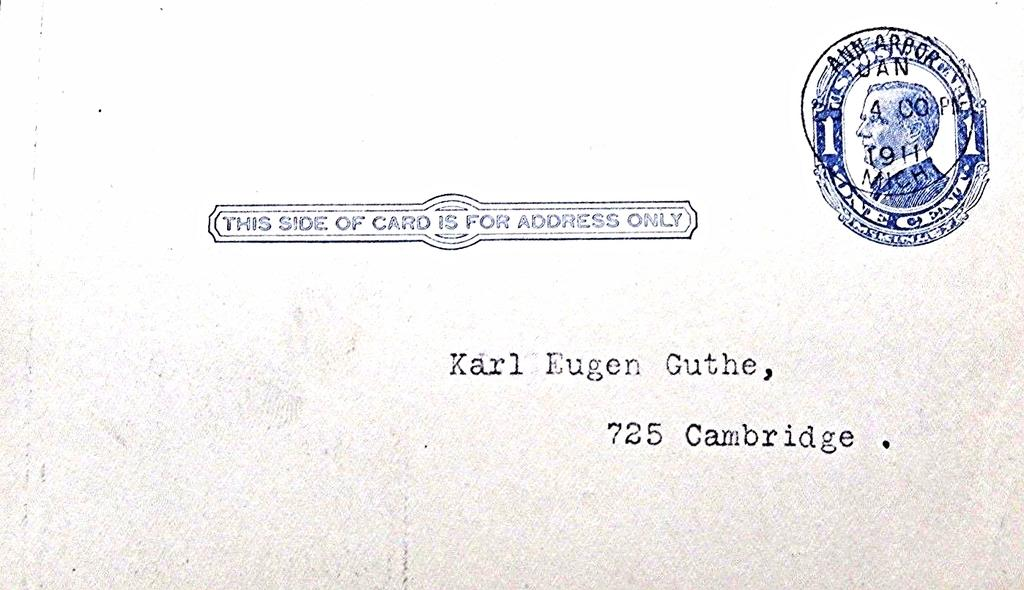<image>
Summarize the visual content of the image. The old envelope from 1911 is addressed to Karl Eugen Guthe at 725 Cambridge. 